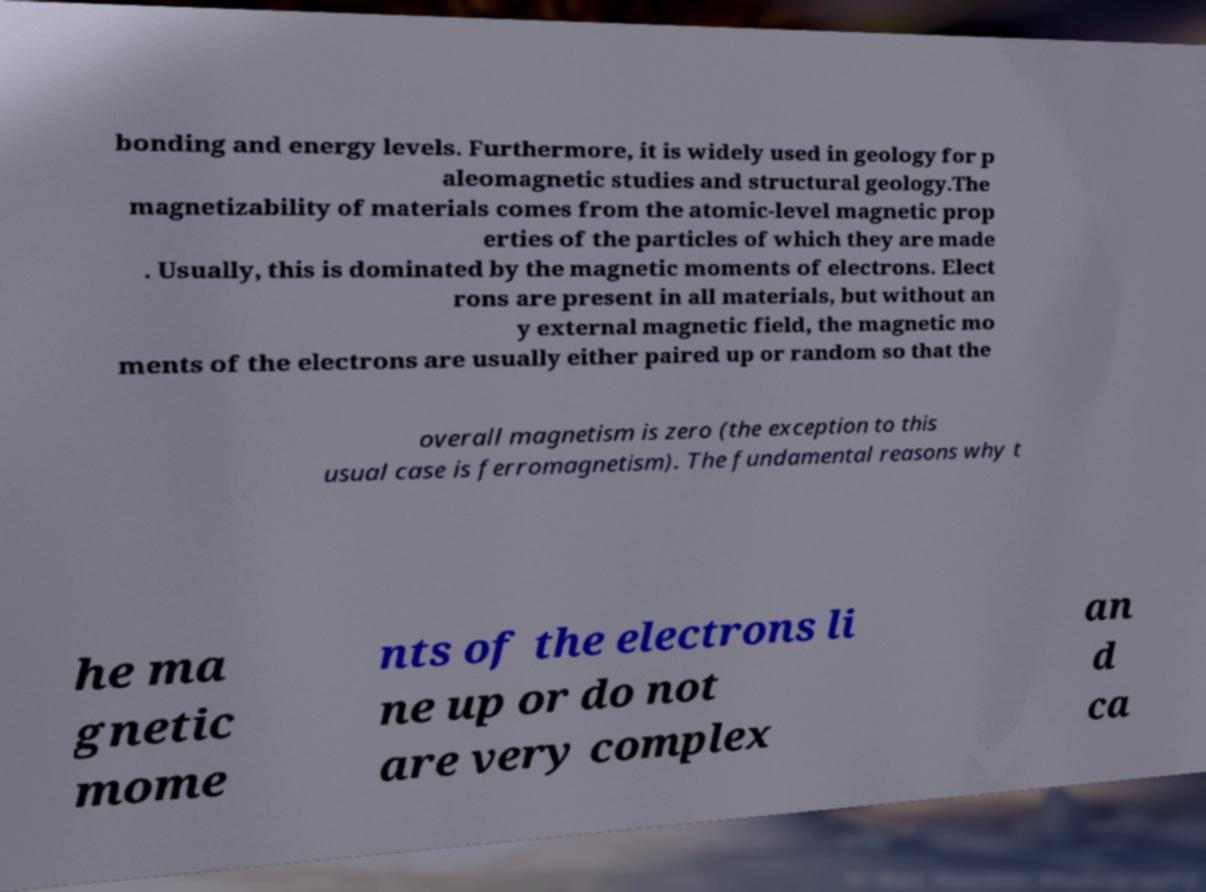Can you read and provide the text displayed in the image?This photo seems to have some interesting text. Can you extract and type it out for me? bonding and energy levels. Furthermore, it is widely used in geology for p aleomagnetic studies and structural geology.The magnetizability of materials comes from the atomic-level magnetic prop erties of the particles of which they are made . Usually, this is dominated by the magnetic moments of electrons. Elect rons are present in all materials, but without an y external magnetic field, the magnetic mo ments of the electrons are usually either paired up or random so that the overall magnetism is zero (the exception to this usual case is ferromagnetism). The fundamental reasons why t he ma gnetic mome nts of the electrons li ne up or do not are very complex an d ca 